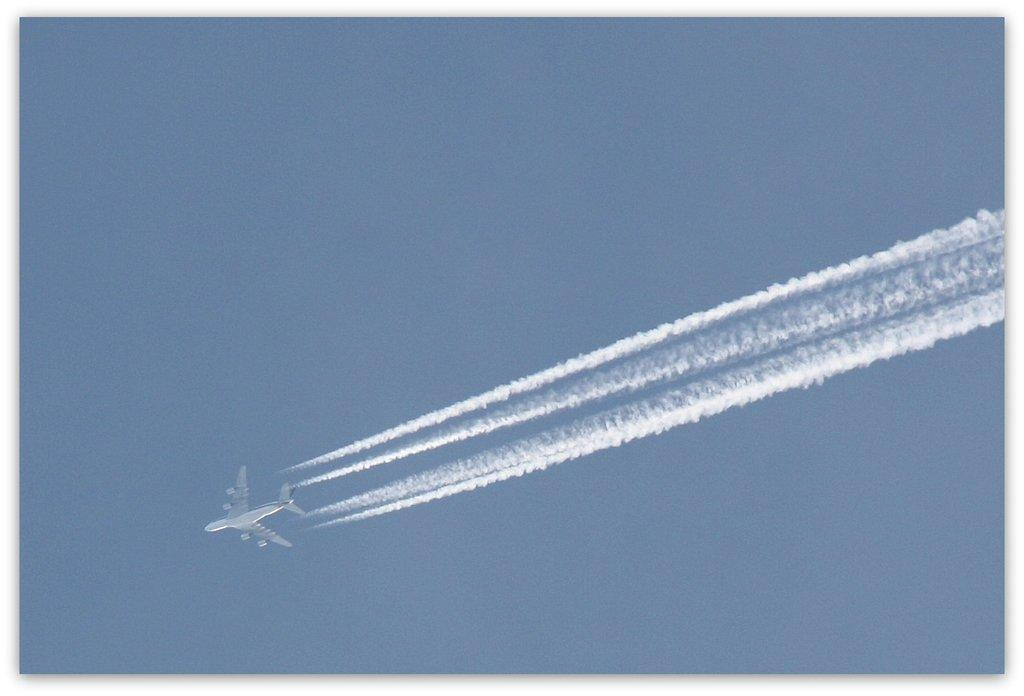What is the main subject of the image? The main subject of the image is an airplane. What is the airplane doing in the image? The airplane is flying in the air. What else can be seen in the image besides the airplane? There is smoke visible in the image. What type of rail can be seen in the image? There is no rail present in the image; it features an airplane flying in the air. Can you describe the farmer working in the field in the image? There is no farmer or field present in the image; it only shows an airplane flying and smoke visible. 